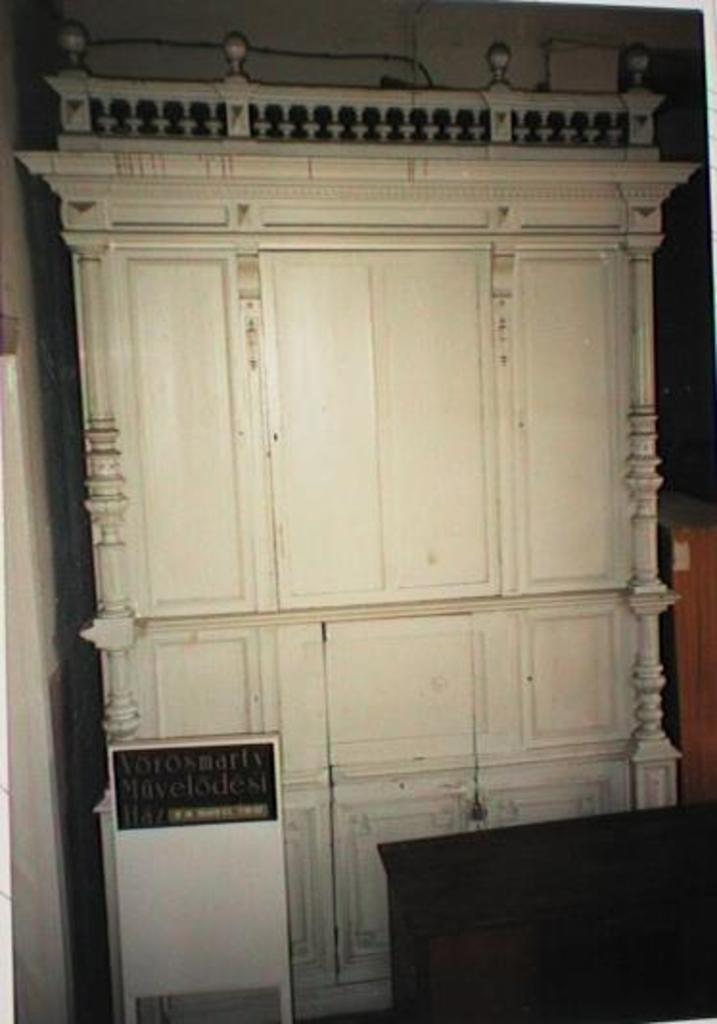Please provide a concise description of this image. In this picture I can see a white color cupboard and a board which has something written on it. On the right side I can see some other objects. 